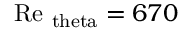Convert formula to latex. <formula><loc_0><loc_0><loc_500><loc_500>R e _ { \ t h e t a } = 6 7 0</formula> 